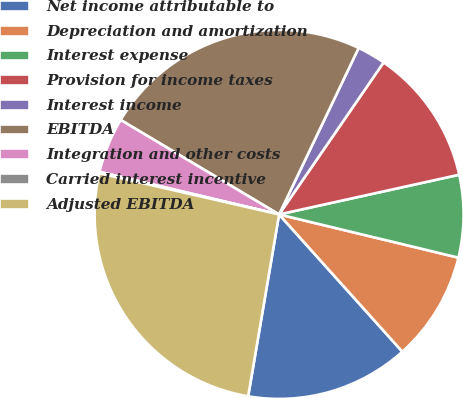Convert chart to OTSL. <chart><loc_0><loc_0><loc_500><loc_500><pie_chart><fcel>Net income attributable to<fcel>Depreciation and amortization<fcel>Interest expense<fcel>Provision for income taxes<fcel>Interest income<fcel>EBITDA<fcel>Integration and other costs<fcel>Carried interest incentive<fcel>Adjusted EBITDA<nl><fcel>14.33%<fcel>9.59%<fcel>7.22%<fcel>11.96%<fcel>2.49%<fcel>23.54%<fcel>4.85%<fcel>0.12%<fcel>25.91%<nl></chart> 